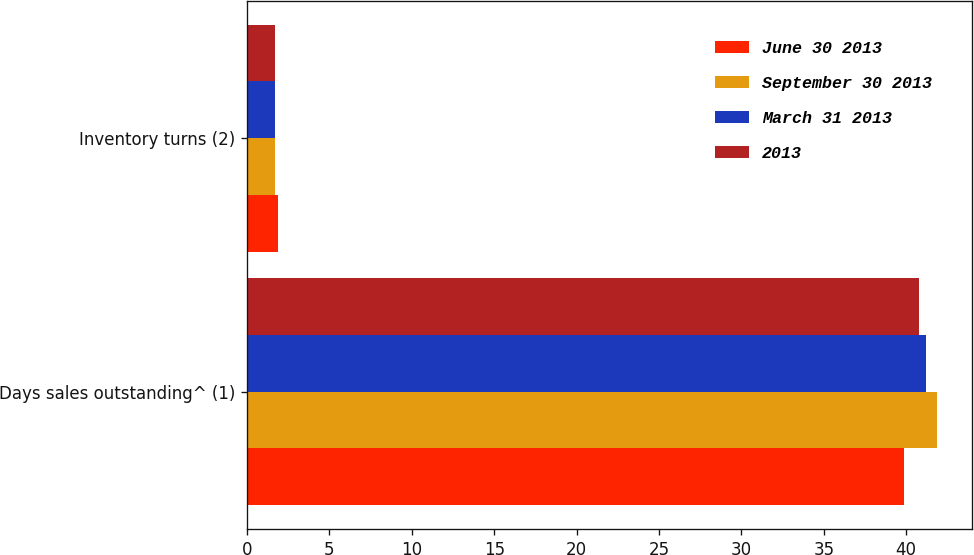Convert chart to OTSL. <chart><loc_0><loc_0><loc_500><loc_500><stacked_bar_chart><ecel><fcel>Days sales outstanding^ (1)<fcel>Inventory turns (2)<nl><fcel>June 30 2013<fcel>39.9<fcel>1.9<nl><fcel>September 30 2013<fcel>41.9<fcel>1.7<nl><fcel>March 31 2013<fcel>41.2<fcel>1.7<nl><fcel>2013<fcel>40.8<fcel>1.7<nl></chart> 